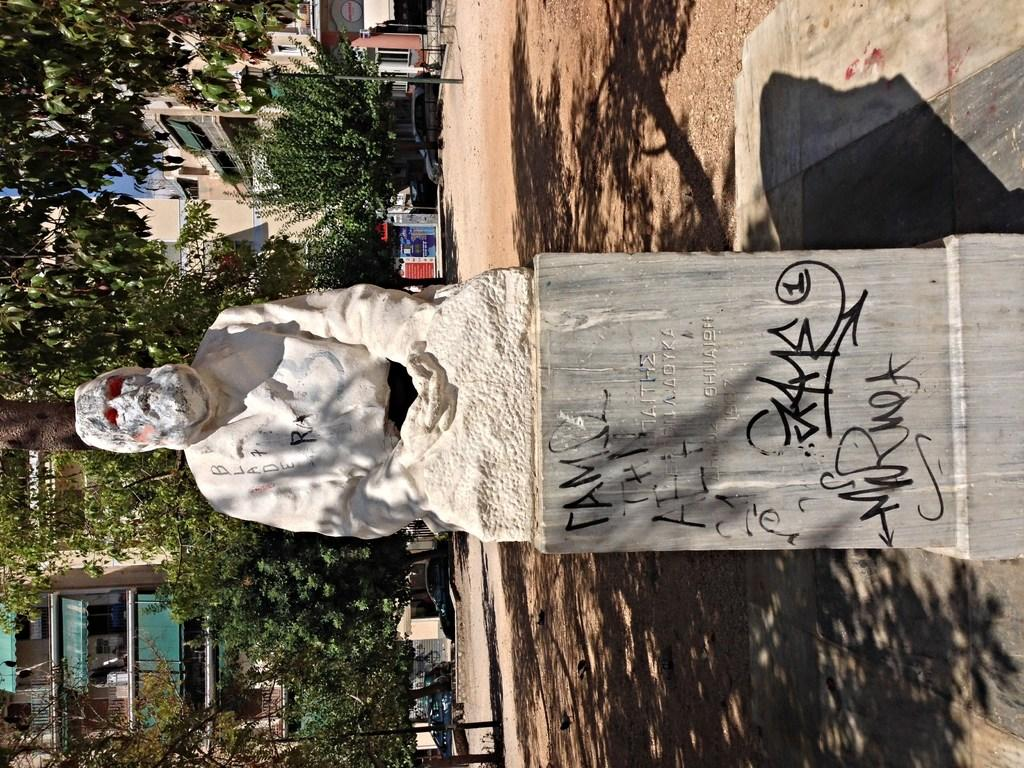What is written on in the image? There is writing on a stone in the image. What is located above the stone? There is a statue above the stone. What can be seen in the background of the image? There are trees, buildings, and vehicles in the background of the image. What type of quince is growing on the side of the statue in the image? There is no quince present in the image, and the statue does not have any growths on its side. 